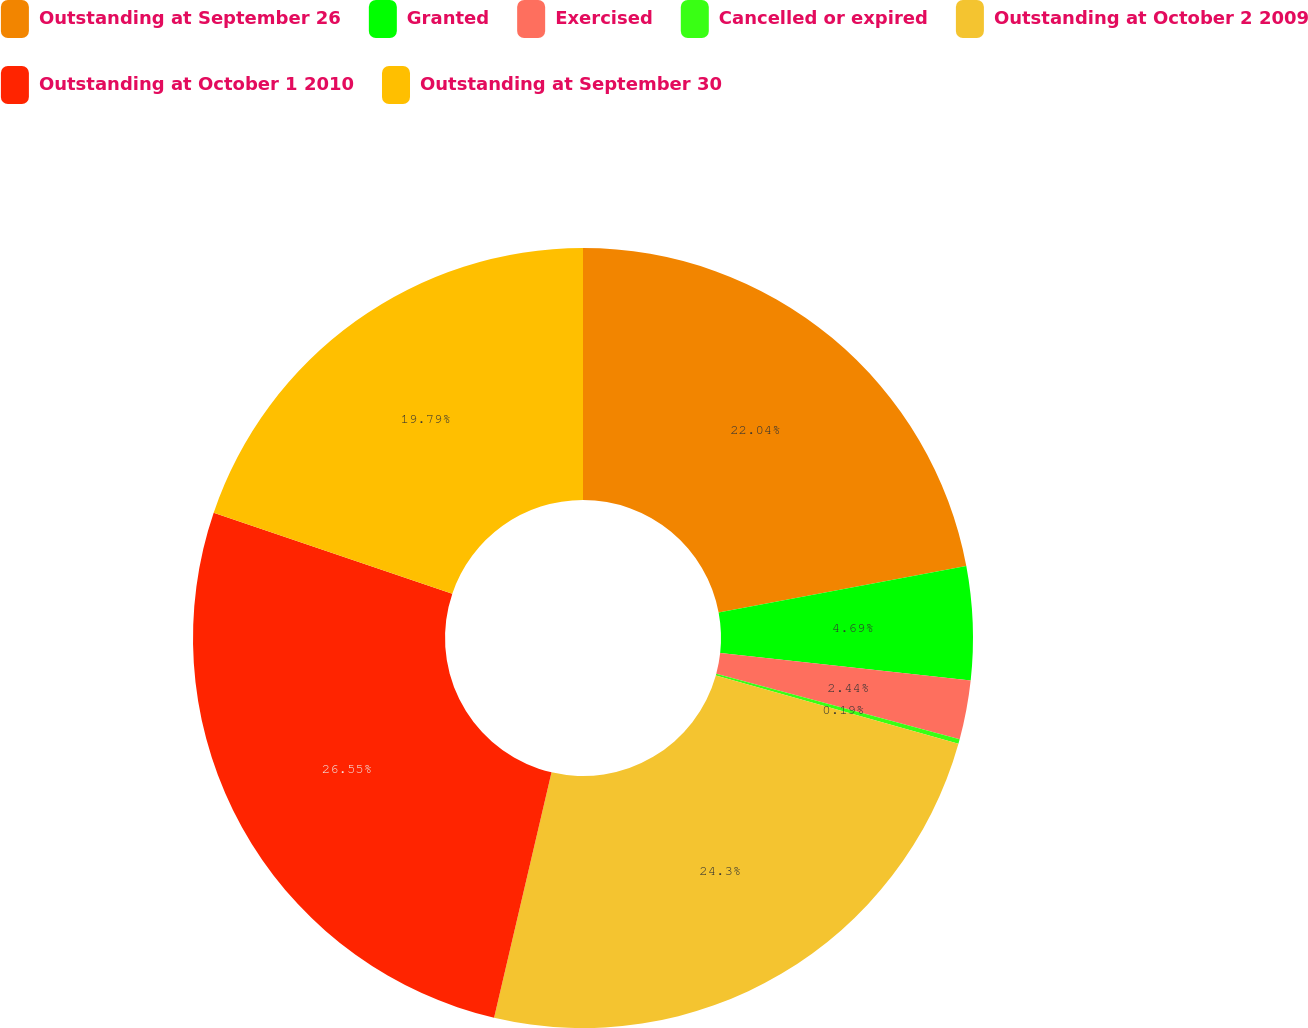<chart> <loc_0><loc_0><loc_500><loc_500><pie_chart><fcel>Outstanding at September 26<fcel>Granted<fcel>Exercised<fcel>Cancelled or expired<fcel>Outstanding at October 2 2009<fcel>Outstanding at October 1 2010<fcel>Outstanding at September 30<nl><fcel>22.04%<fcel>4.69%<fcel>2.44%<fcel>0.19%<fcel>24.29%<fcel>26.54%<fcel>19.79%<nl></chart> 